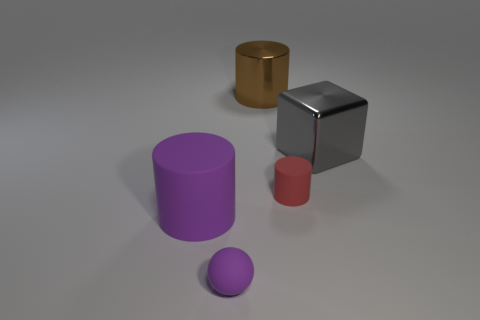What is the shape of the large object in front of the metallic thing right of the red thing?
Your answer should be compact. Cylinder. Does the purple thing that is in front of the purple matte cylinder have the same material as the large object that is in front of the large gray block?
Ensure brevity in your answer.  Yes. What number of rubber things are right of the big shiny thing that is behind the gray shiny object?
Offer a very short reply. 1. There is a purple rubber object on the left side of the matte sphere; is it the same shape as the tiny matte object that is behind the purple rubber cylinder?
Keep it short and to the point. Yes. There is a cylinder that is both to the left of the tiny red rubber cylinder and in front of the big gray shiny object; what is its size?
Your answer should be compact. Large. The other tiny matte thing that is the same shape as the brown object is what color?
Your answer should be very brief. Red. There is a big cylinder behind the rubber cylinder to the right of the small purple matte ball; what is its color?
Ensure brevity in your answer.  Brown. What is the shape of the gray object?
Provide a succinct answer. Cube. The large thing that is both left of the big gray thing and right of the purple cylinder has what shape?
Your answer should be compact. Cylinder. The large thing that is made of the same material as the small cylinder is what color?
Provide a succinct answer. Purple. 